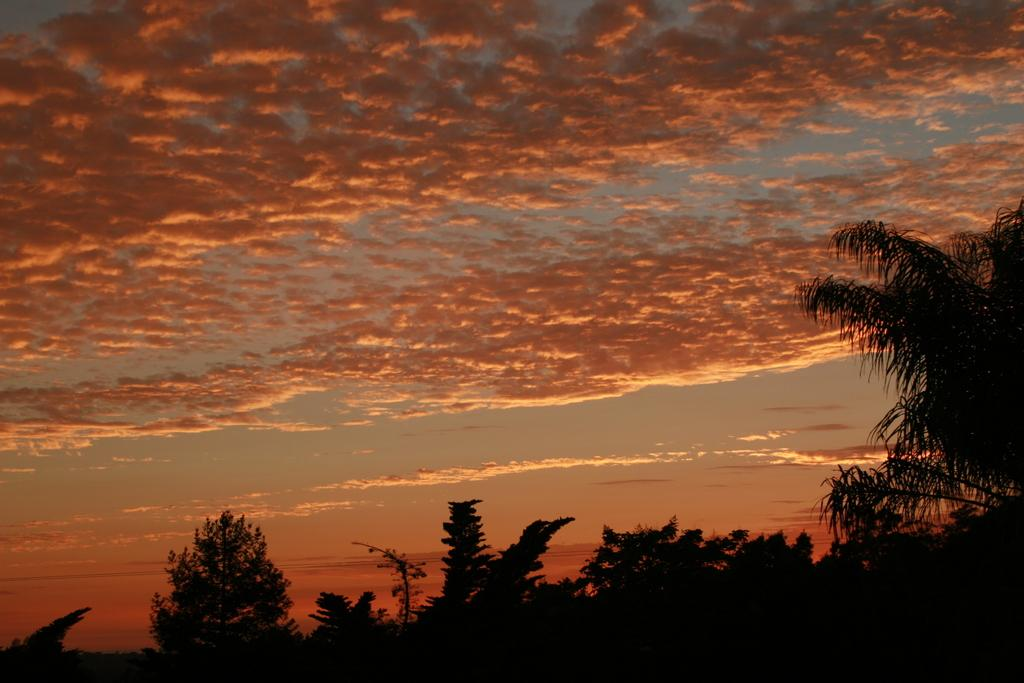What type of vegetation can be seen in the image? There are trees in the image. What part of the natural environment is visible in the image? The sky is visible in the image. What colors can be observed in the sky in the image? The colors of the sky in the image include orange, grey, and white. How many cattle are grazing in the image? There are no cattle present in the image. Can you see any bats flying in the sky in the image? There are no bats visible in the sky in the image. Is there any indication of someone saying good-bye in the image? There is no indication of anyone saying good-bye in the image. 